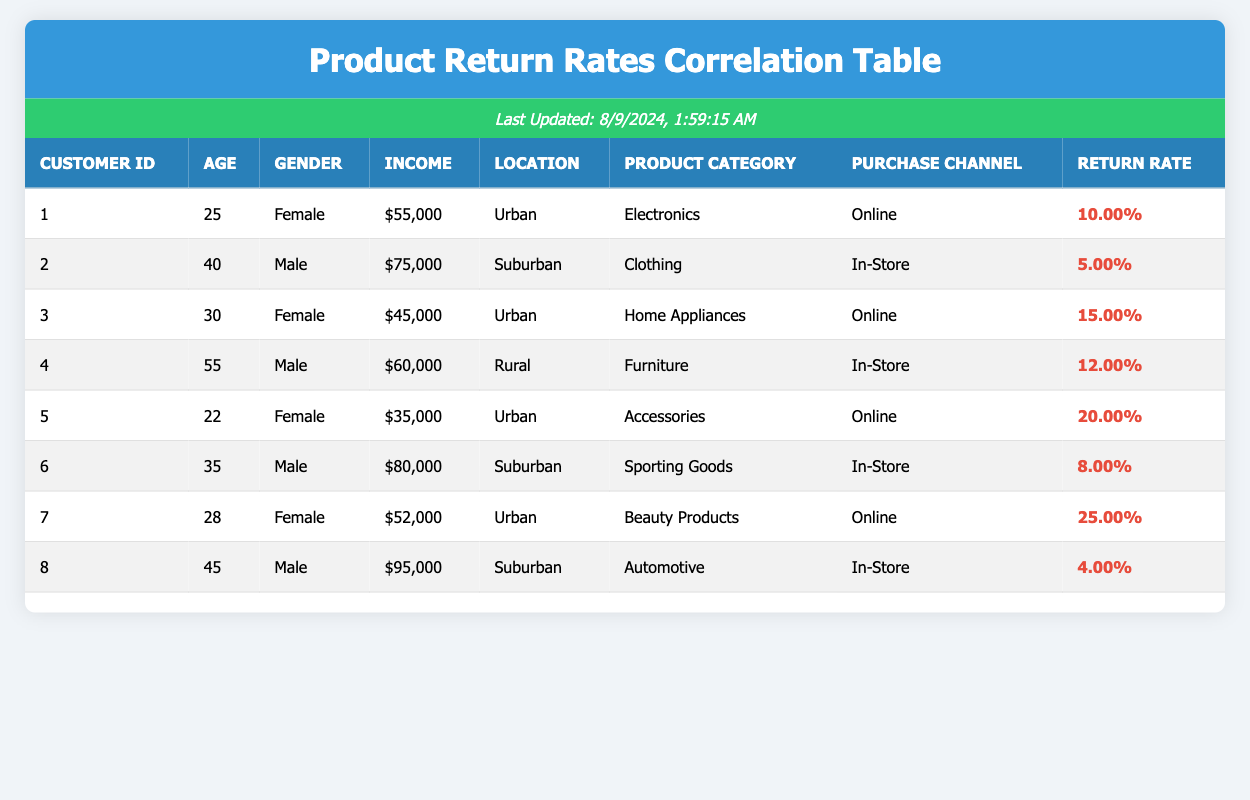What is the return rate for customer ID 5? The return rate for customer ID 5 is found in the "Return Rate" column of the table. According to the data for customer ID 5, it shows a return rate of 20.00%.
Answer: 20.00% What is the age of the customer who has the highest return rate? The highest return rate in the table is 25.00%, associated with customer ID 7. In the "Age" column for this customer, it indicates that the age is 28.
Answer: 28 Is there a noticeable difference in return rates between male and female customers? To determine this, we compare the return rates of male and female customers in the table. Male customers have return rates of 5.00%, 12.00%, and 8.00%, averaging to 8.33%. Female customers have return rates of 10.00%, 15.00%, 20.00%, and 25.00%, averaging to 17.50%. The average return rate for female customers is higher than that of male customers, indicating a difference.
Answer: Yes What is the average return rate for customers from urban locations? To calculate the average return rate for urban customers, we first identify those customers in the data: IDs 1, 3, 5, and 7. Their return rates are 10.00%, 15.00%, 20.00%, and 25.00%, respectively. We then sum these return rates: 10 + 15 + 20 + 25 = 70. Dividing this sum by the number of urban customers (4) gives us an average return rate of 70/4 = 17.50%.
Answer: 17.50% Which product category has the highest return rate overall? To determine which product category has the highest return rate, we look at the "Return Rate" for each category: Electronics (10.00%), Clothing (5.00%), Home Appliances (15.00%), Furniture (12.00%), Accessories (20.00%), Sporting Goods (8.00%), Beauty Products (25.00%), and Automotive (4.00%). The highest return rate is found in the Beauty Products category with a rate of 25.00%.
Answer: Beauty Products What is the return rate difference between the highest and lowest return rates? The highest return rate is 25.00% (Beauty Products) while the lowest return rate is 4.00% (Automotive). To find the return rate difference, we subtract the lowest from the highest: 25.00% - 4.00% = 21.00%.
Answer: 21.00% Do customers who purchase online generally have higher return rates than those who shop in-store? To assess this, we evaluate the return rates based on the purchase channel. Online purchases have return rates of 10.00%, 15.00%, 20.00%, and 25.00% which average to (10 + 15 + 20 + 25) / 4 = 17.50%. In-store purchases have return rates of 5.00%, 12.00%, 8.00% which average to (5 + 12 + 8) / 3 = 8.33%. The online average is higher than the in-store average, indicating that online shoppers generally return products more.
Answer: Yes What is the overall average income of customers who returned products? We sum the incomes of all customers (55000 + 75000 + 45000 + 60000 + 35000 + 80000 + 52000 + 95000 = 395000) and divide by the total number of customers (8) to find the average: 395000 / 8 = 49375.
Answer: 49375 